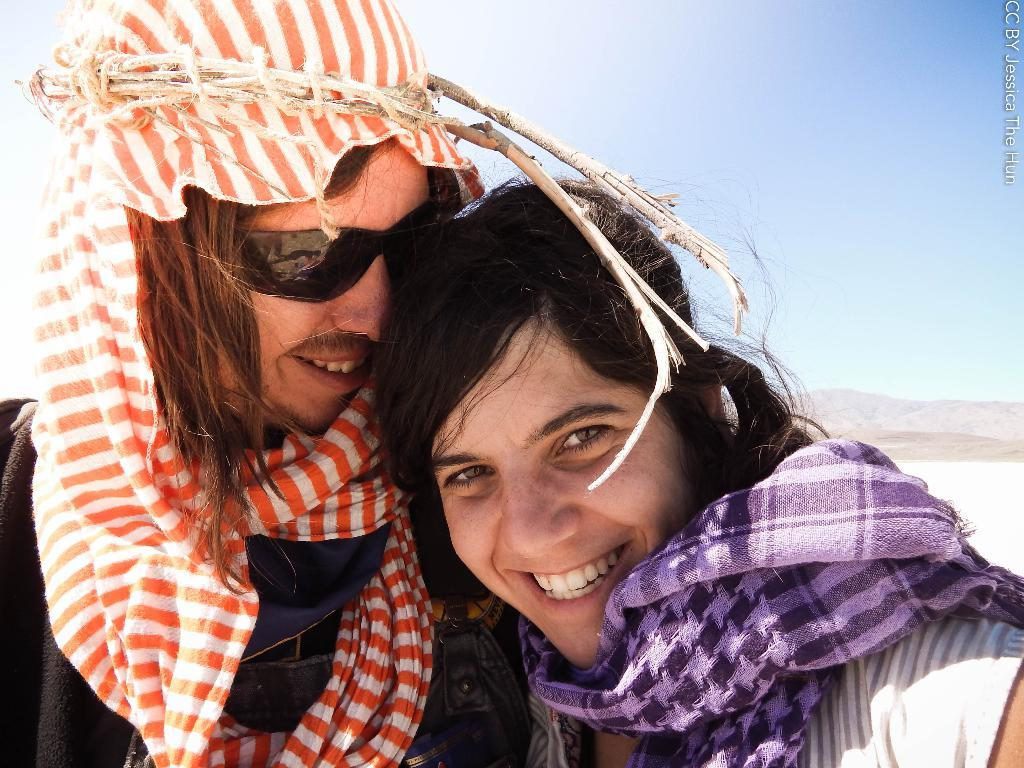Who is present in the image? There is a woman and a man in the image. What are the expressions on their faces? Both the woman and the man are smiling. What is the man wearing on his face? The man is wearing goggles. What can be seen in the background of the image? There is a mountain and the sky visible in the background of the image. How many giraffes are visible in the image? There are no giraffes present in the image. What type of cars can be seen in the background of the image? There are no cars visible in the image; it features a mountain and the sky in the background. 